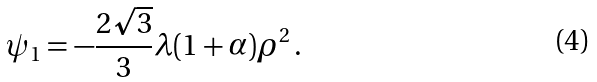Convert formula to latex. <formula><loc_0><loc_0><loc_500><loc_500>\psi _ { 1 } = - \frac { 2 \sqrt { 3 } } { 3 } \lambda ( 1 + \alpha ) \rho ^ { 2 } \, .</formula> 